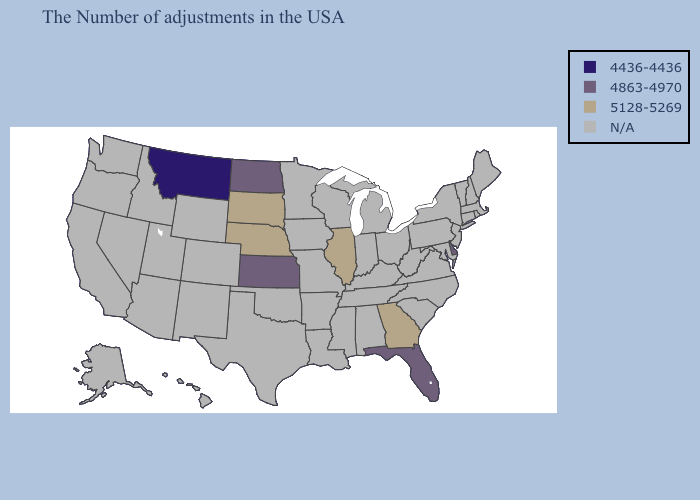What is the value of South Dakota?
Keep it brief. 5128-5269. Among the states that border Colorado , does Kansas have the lowest value?
Answer briefly. Yes. Does the first symbol in the legend represent the smallest category?
Keep it brief. Yes. Among the states that border Alabama , does Florida have the lowest value?
Be succinct. Yes. Name the states that have a value in the range N/A?
Answer briefly. Maine, Massachusetts, Rhode Island, New Hampshire, Vermont, Connecticut, New York, New Jersey, Maryland, Pennsylvania, Virginia, North Carolina, South Carolina, West Virginia, Ohio, Michigan, Kentucky, Indiana, Alabama, Tennessee, Wisconsin, Mississippi, Louisiana, Missouri, Arkansas, Minnesota, Iowa, Oklahoma, Texas, Wyoming, Colorado, New Mexico, Utah, Arizona, Idaho, Nevada, California, Washington, Oregon, Alaska, Hawaii. What is the value of Massachusetts?
Short answer required. N/A. What is the value of Massachusetts?
Be succinct. N/A. How many symbols are there in the legend?
Quick response, please. 4. What is the lowest value in the USA?
Short answer required. 4436-4436. Among the states that border Oklahoma , which have the lowest value?
Answer briefly. Kansas. Among the states that border Colorado , does Kansas have the highest value?
Give a very brief answer. No. What is the value of North Carolina?
Answer briefly. N/A. 